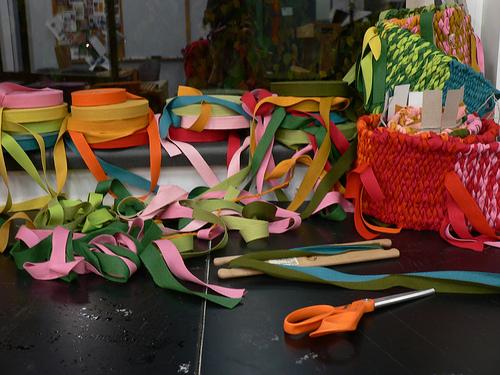Was this picture taken out of focus?
Write a very short answer. No. Why is the table so messy?
Answer briefly. Ribbons everywhere. What color is the  basket?
Concise answer only. Red. What are the ribbons for?
Be succinct. Decorating. What color is the scissor handle?
Quick response, please. Orange. What color is the countertop in the foreground?
Quick response, please. Black. What are the primary colors appearing in the picture?
Answer briefly. Red. Are there any blue ribbons?
Keep it brief. Yes. What color ribbon is the tip of the scissors touching?
Answer briefly. Green. 